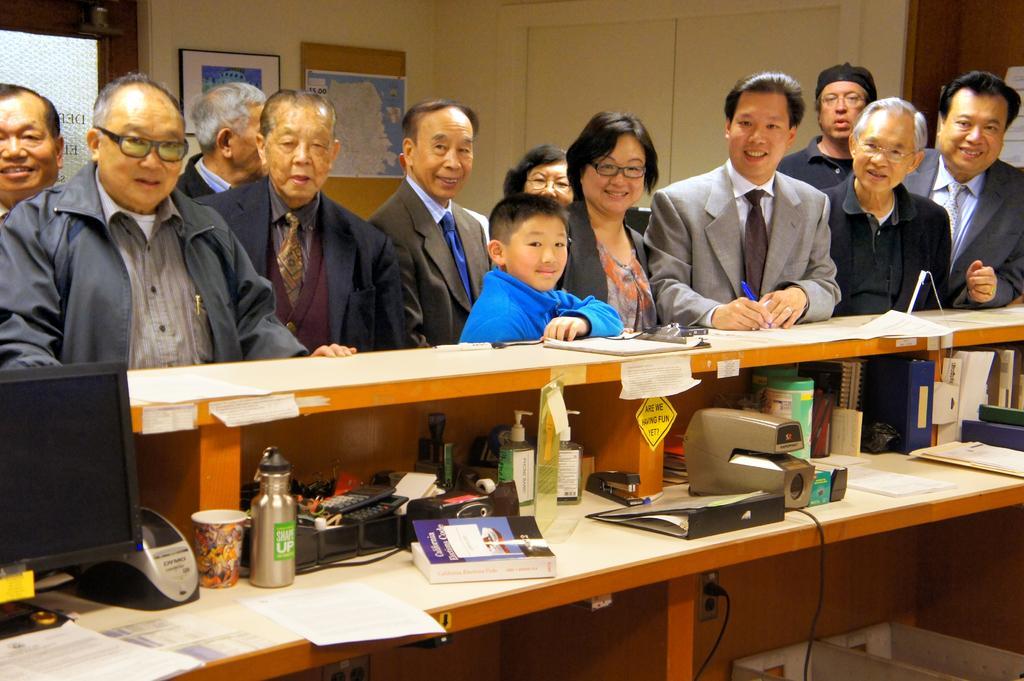How would you summarize this image in a sentence or two? In this image i can see a group of people are standing in front of a desk. On the table we have a monitor a bottle and other objects on it. 